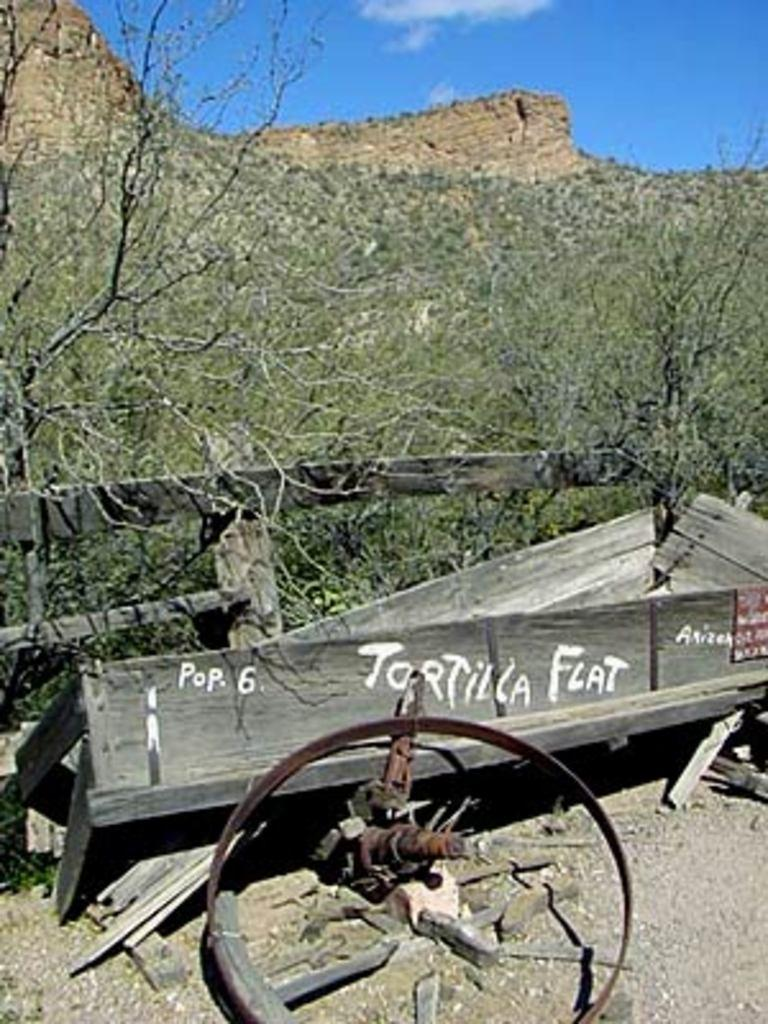What is the condition of the cart in the image? The cart in the image is broken. What type of barrier is present in the image? There is a wooden fence in the image. What type of vegetation is visible in the image? There are trees in the image. What type of geographical feature is visible in the image? There is a mountain in the image. How would you describe the sky in the image? The sky is cloudy and pale blue in the image. What type of secretary can be seen working in the image? There is no secretary present in the image; it features a broken cart, a wooden fence, trees, a mountain, and a cloudy, pale blue sky. How many times does the lift go up and down in the image? There is no lift present in the image; it features a broken cart, a wooden fence, trees, a mountain, and a cloudy, pale blue sky. 